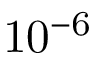<formula> <loc_0><loc_0><loc_500><loc_500>1 0 ^ { - 6 }</formula> 